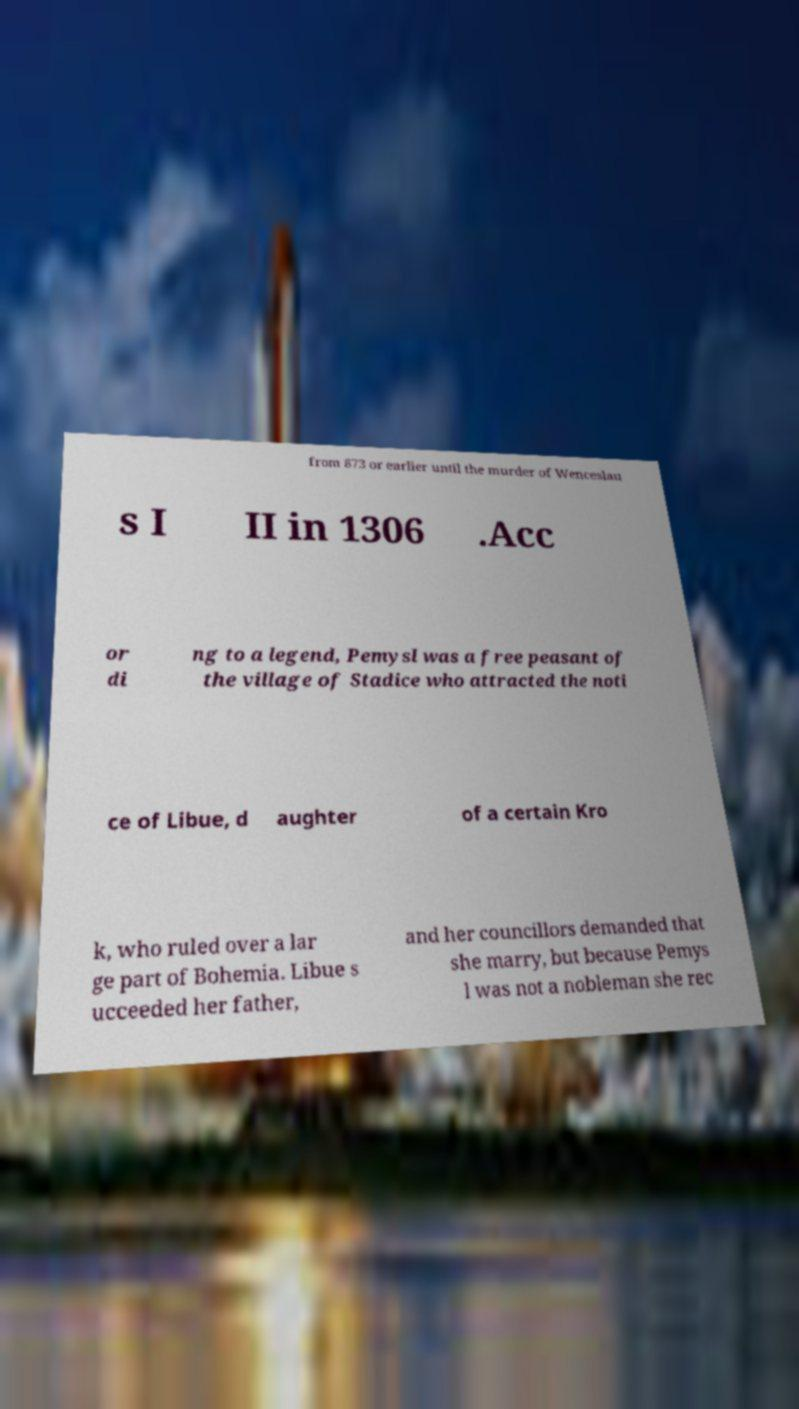For documentation purposes, I need the text within this image transcribed. Could you provide that? from 873 or earlier until the murder of Wenceslau s I II in 1306 .Acc or di ng to a legend, Pemysl was a free peasant of the village of Stadice who attracted the noti ce of Libue, d aughter of a certain Kro k, who ruled over a lar ge part of Bohemia. Libue s ucceeded her father, and her councillors demanded that she marry, but because Pemys l was not a nobleman she rec 